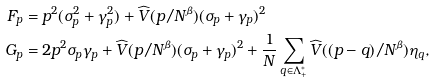Convert formula to latex. <formula><loc_0><loc_0><loc_500><loc_500>F _ { p } = \, & p ^ { 2 } ( \sigma _ { p } ^ { 2 } + \gamma _ { p } ^ { 2 } ) + \widehat { V } ( p / N ^ { \beta } ) ( \sigma _ { p } + \gamma _ { p } ) ^ { 2 } \\ G _ { p } = \, & 2 p ^ { 2 } \sigma _ { p } \gamma _ { p } + \widehat { V } ( p / N ^ { \beta } ) ( \sigma _ { p } + \gamma _ { p } ) ^ { 2 } + \frac { 1 } { N } \sum _ { q \in \Lambda _ { + } ^ { * } } \widehat { V } ( ( p - q ) / N ^ { \beta } ) \eta _ { q } ,</formula> 